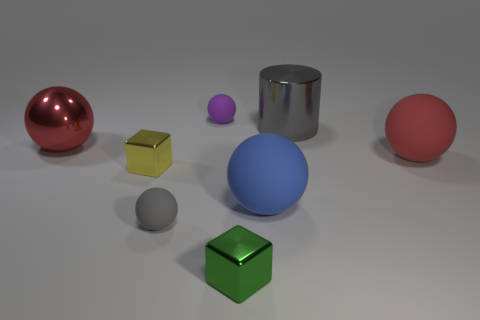What color is the shiny ball that is the same size as the gray metallic cylinder?
Offer a very short reply. Red. How many purple things are behind the gray metallic cylinder?
Your response must be concise. 1. Are there any purple spheres made of the same material as the tiny purple object?
Make the answer very short. No. The small matte object that is the same color as the big cylinder is what shape?
Give a very brief answer. Sphere. What is the color of the big rubber sphere that is to the left of the large gray metallic cylinder?
Your answer should be very brief. Blue. Are there the same number of small yellow shiny things that are on the right side of the tiny purple matte ball and metal blocks that are left of the green metal block?
Provide a short and direct response. No. What is the material of the big red ball that is on the right side of the small purple matte ball left of the large blue rubber thing?
Offer a very short reply. Rubber. What number of things are yellow shiny things or large things in front of the shiny ball?
Ensure brevity in your answer.  3. There is a ball that is made of the same material as the tiny yellow object; what size is it?
Your response must be concise. Large. Is the number of big red matte balls that are left of the yellow object greater than the number of yellow metal blocks?
Offer a very short reply. No. 